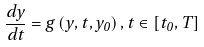Convert formula to latex. <formula><loc_0><loc_0><loc_500><loc_500>\frac { d y } { d t } = g \left ( y , t , y _ { 0 } \right ) , t \in \left [ t _ { 0 } , T \right ]</formula> 